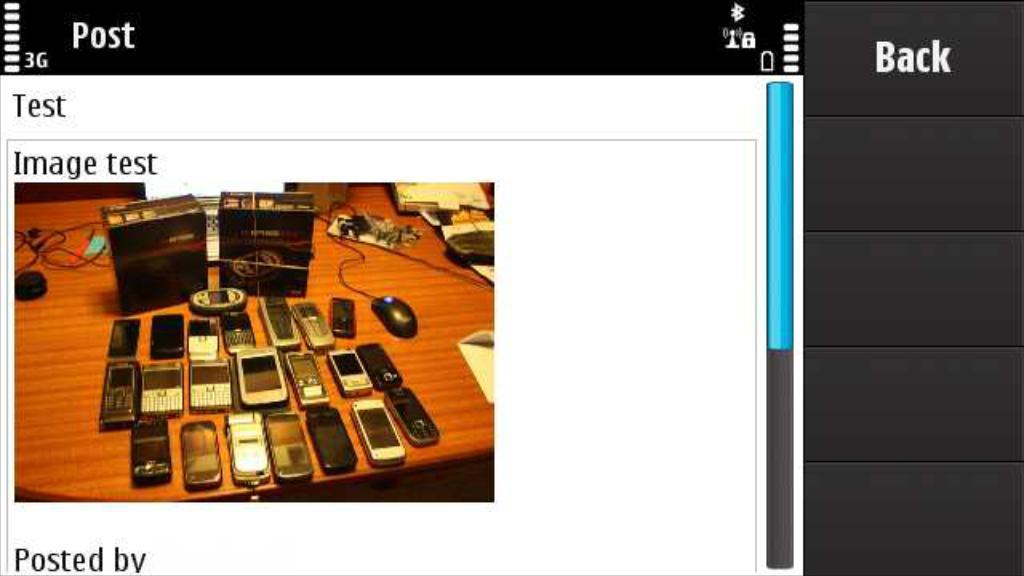What button is in the top right?
Your answer should be very brief. Back. 